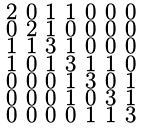Convert formula to latex. <formula><loc_0><loc_0><loc_500><loc_500>\begin{smallmatrix} 2 & 0 & 1 & 1 & 0 & 0 & 0 \\ 0 & 2 & 1 & 0 & 0 & 0 & 0 \\ 1 & 1 & 3 & 1 & 0 & 0 & 0 \\ 1 & 0 & 1 & 3 & 1 & 1 & 0 \\ 0 & 0 & 0 & 1 & 3 & 0 & 1 \\ 0 & 0 & 0 & 1 & 0 & 3 & 1 \\ 0 & 0 & 0 & 0 & 1 & 1 & 3 \end{smallmatrix}</formula> 